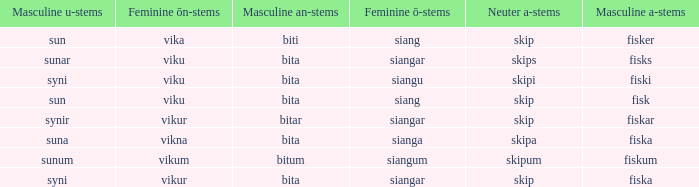What is the masculine an form for the word with a feminine ö ending of siangar and a masculine u ending of sunar? Bita. 